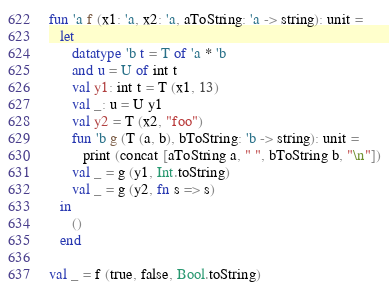<code> <loc_0><loc_0><loc_500><loc_500><_SML_>fun 'a f (x1: 'a, x2: 'a, aToString: 'a -> string): unit =
   let
      datatype 'b t = T of 'a * 'b
      and u = U of int t
      val y1: int t = T (x1, 13)
      val _: u = U y1
      val y2 = T (x2, "foo")
      fun 'b g (T (a, b), bToString: 'b -> string): unit =
         print (concat [aToString a, " ", bToString b, "\n"])
      val _ = g (y1, Int.toString)
      val _ = g (y2, fn s => s)
   in
      ()
   end

val _ = f (true, false, Bool.toString)
</code> 